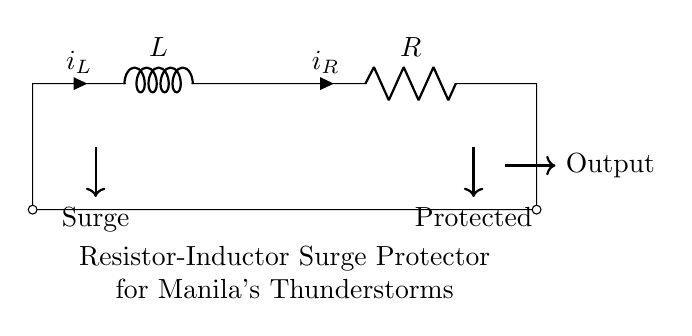What is the inductor labeled as in the diagram? The inductor is labeled as "L," indicating its inductance component in the circuit.
Answer: L What does the current direction of the inductor indicate? The arrow for the inductor shows the direction of current flow as "i_L," which indicates it is flowing through the inductor.
Answer: i_L What component is used for surge protection in this circuit? The circuit utilizes a resistor-inductor combination to manage surge protection effectively.
Answer: Resistor-Inductor What happens to the surge according to the diagram? The arrow from the surge indicates that it enters the circuit at the inductor and goes toward the output connection, illustrating the flow of excessive energy.
Answer: Surge enters What is the function of the resistor in this surge protector? The resistor limits the current flow and dissipates energy, helping to protect connected devices during a surge.
Answer: Limits current What is the expected output after the surge passes through the circuit? The output connection shows that after the surge has been managed by the inductor and resistor, the output to the protected devices will be safe from excess voltage/current.
Answer: Safe output What does the label "Protected" signify in the diagram? The "Protected" label denotes the area or devices that are shielded against voltage spikes and disturbances due to the operational behavior of the inductor and resistor.
Answer: Protected devices 